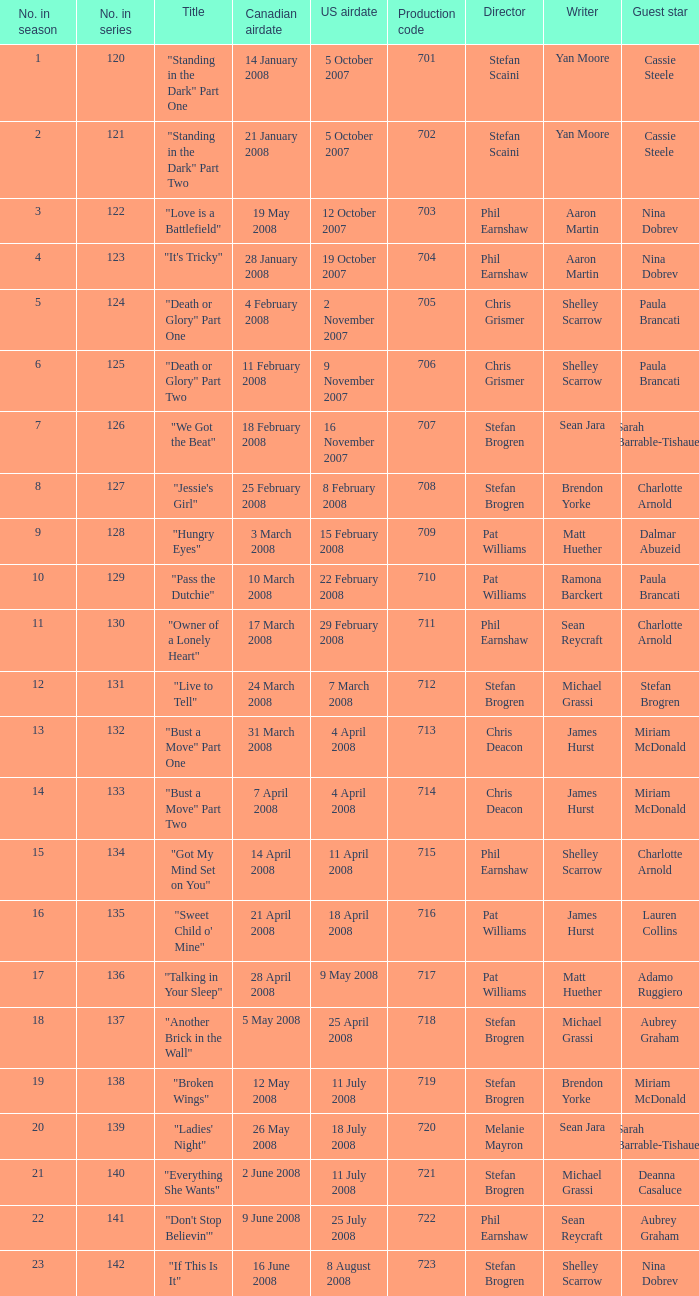The canadian airdate of 17 march 2008 had how many numbers in the season? 1.0. 